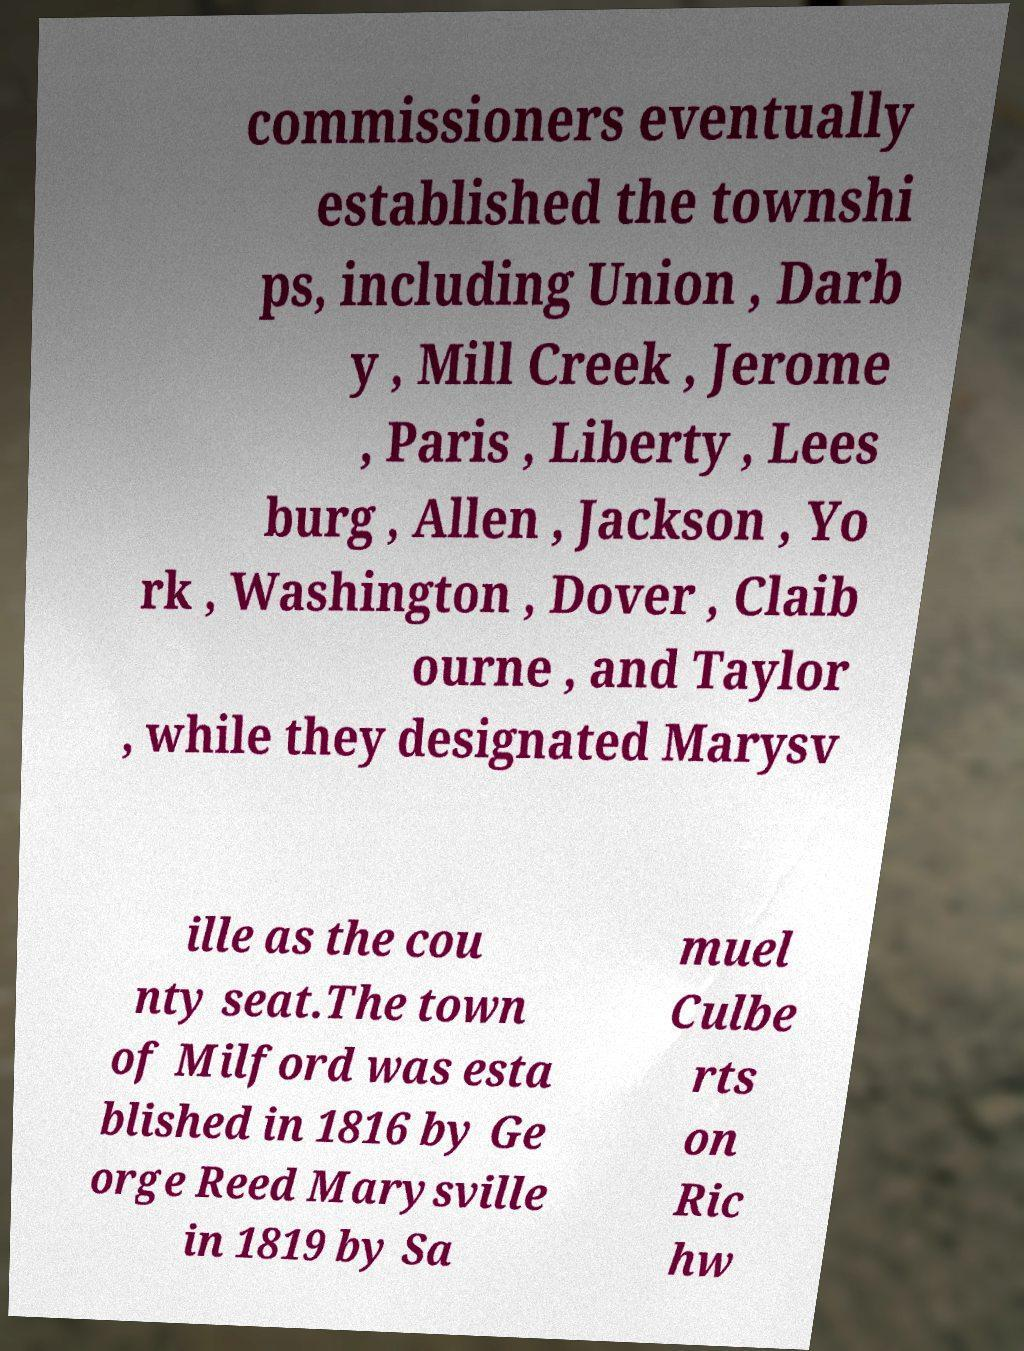I need the written content from this picture converted into text. Can you do that? commissioners eventually established the townshi ps, including Union , Darb y , Mill Creek , Jerome , Paris , Liberty , Lees burg , Allen , Jackson , Yo rk , Washington , Dover , Claib ourne , and Taylor , while they designated Marysv ille as the cou nty seat.The town of Milford was esta blished in 1816 by Ge orge Reed Marysville in 1819 by Sa muel Culbe rts on Ric hw 